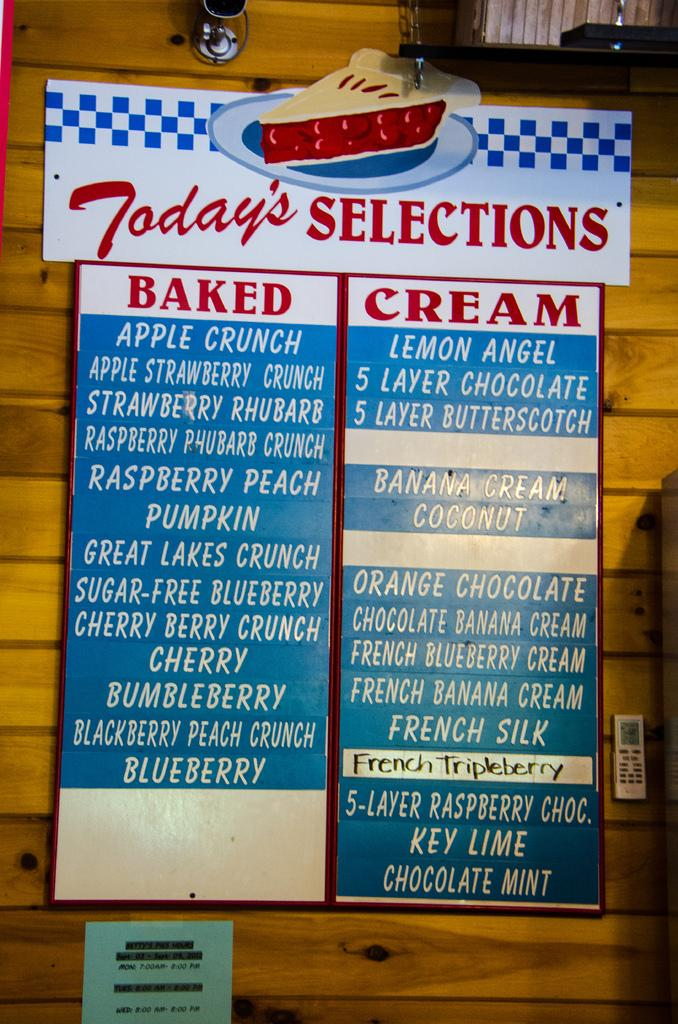<image>
Give a short and clear explanation of the subsequent image. A sign for deserts that says today's selections. 